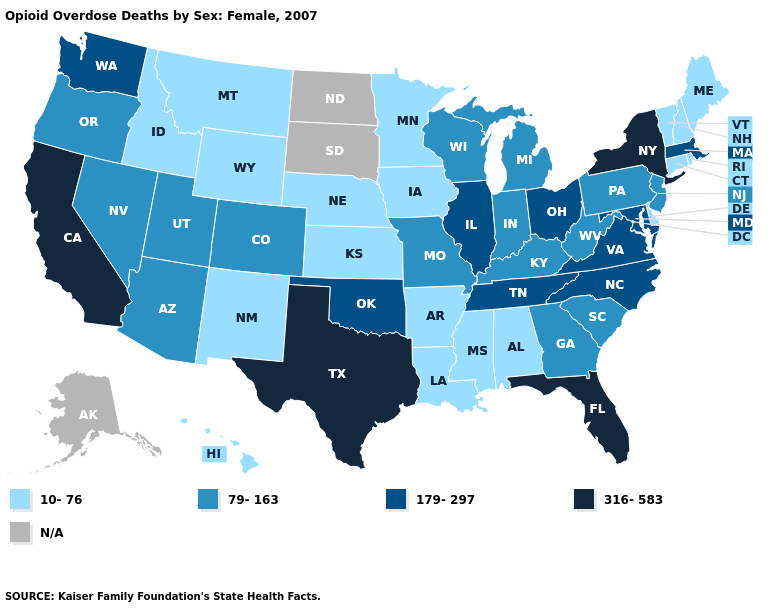What is the highest value in states that border Georgia?
Concise answer only. 316-583. Name the states that have a value in the range 10-76?
Quick response, please. Alabama, Arkansas, Connecticut, Delaware, Hawaii, Idaho, Iowa, Kansas, Louisiana, Maine, Minnesota, Mississippi, Montana, Nebraska, New Hampshire, New Mexico, Rhode Island, Vermont, Wyoming. What is the highest value in the USA?
Quick response, please. 316-583. Does the first symbol in the legend represent the smallest category?
Be succinct. Yes. Among the states that border New Hampshire , which have the highest value?
Be succinct. Massachusetts. Name the states that have a value in the range 316-583?
Be succinct. California, Florida, New York, Texas. Name the states that have a value in the range 179-297?
Give a very brief answer. Illinois, Maryland, Massachusetts, North Carolina, Ohio, Oklahoma, Tennessee, Virginia, Washington. Does the map have missing data?
Answer briefly. Yes. What is the highest value in states that border Florida?
Be succinct. 79-163. What is the highest value in the USA?
Short answer required. 316-583. Does Arizona have the lowest value in the West?
Be succinct. No. What is the value of Maine?
Be succinct. 10-76. Does the map have missing data?
Give a very brief answer. Yes. What is the value of Connecticut?
Give a very brief answer. 10-76. 